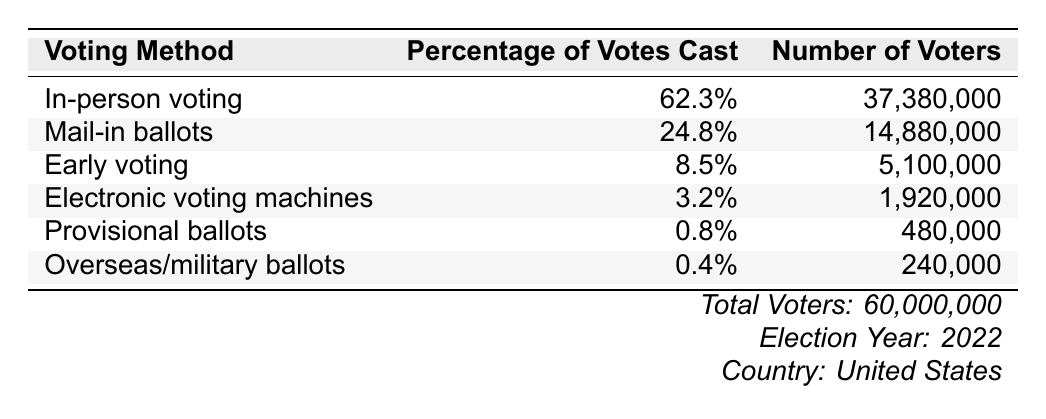What percentage of voters used in-person voting? The table shows that in-person voting accounted for 62.3% of the votes cast.
Answer: 62.3% How many voters cast their votes using mail-in ballots? By looking at the table, the number of voters who used mail-in ballots is listed as 14,880,000.
Answer: 14,880,000 What is the combined percentage of early voting and electronic voting? Early voting is 8.5% and electronic voting is 3.2%. Adding these together gives 8.5% + 3.2% = 11.7%.
Answer: 11.7% Is the number of voters using provisional ballots greater than that using overseas/military ballots? The table shows 480,000 voters used provisional ballots and 240,000 used overseas/military ballots. Since 480,000 is greater than 240,000, the statement is true.
Answer: Yes What percentage of the total votes were cast using methods other than in-person voting? Total percentage of non-in-person votes: Mail-in ballots (24.8%) + Early voting (8.5%) + Electronic voting (3.2%) + Provisional ballots (0.8%) + Overseas/military ballots (0.4%) = 37.7%.
Answer: 37.7% What is the difference in the number of voters between mail-in ballots and electronic voting? The number of voters for mail-in ballots is 14,880,000 and for electronic voting is 1,920,000. The difference is 14,880,000 - 1,920,000 = 12,960,000.
Answer: 12,960,000 How many voters participated in early voting compared to the total number of voters? Early voting had 5,100,000 voters; the total number of voters is 60,000,000. Therefore, the percentage is (5,100,000 / 60,000,000) * 100 = 8.5%, which matches the table.
Answer: 5,100,000 If electronic voting decreased by 1%, how would that change the percentage of votes cast for electronic voting? Currently, the percentage for electronic voting is 3.2%. Decreasing it by 1% gives us 3.2% - 1% = 2.2%.
Answer: 2.2% What is the total number of votes cast if provisional and overseas ballots are included? Provisional ballots: 480,000 and overseas/military ballots: 240,000. Adding together: 480,000 + 240,000 = 720,000.
Answer: 720,000 What voting method had the lowest percentage of votes cast? By examining the table, overseas/military ballots at 0.4% had the lowest percentage of votes cast compared to other methods.
Answer: Overseas/military ballots 